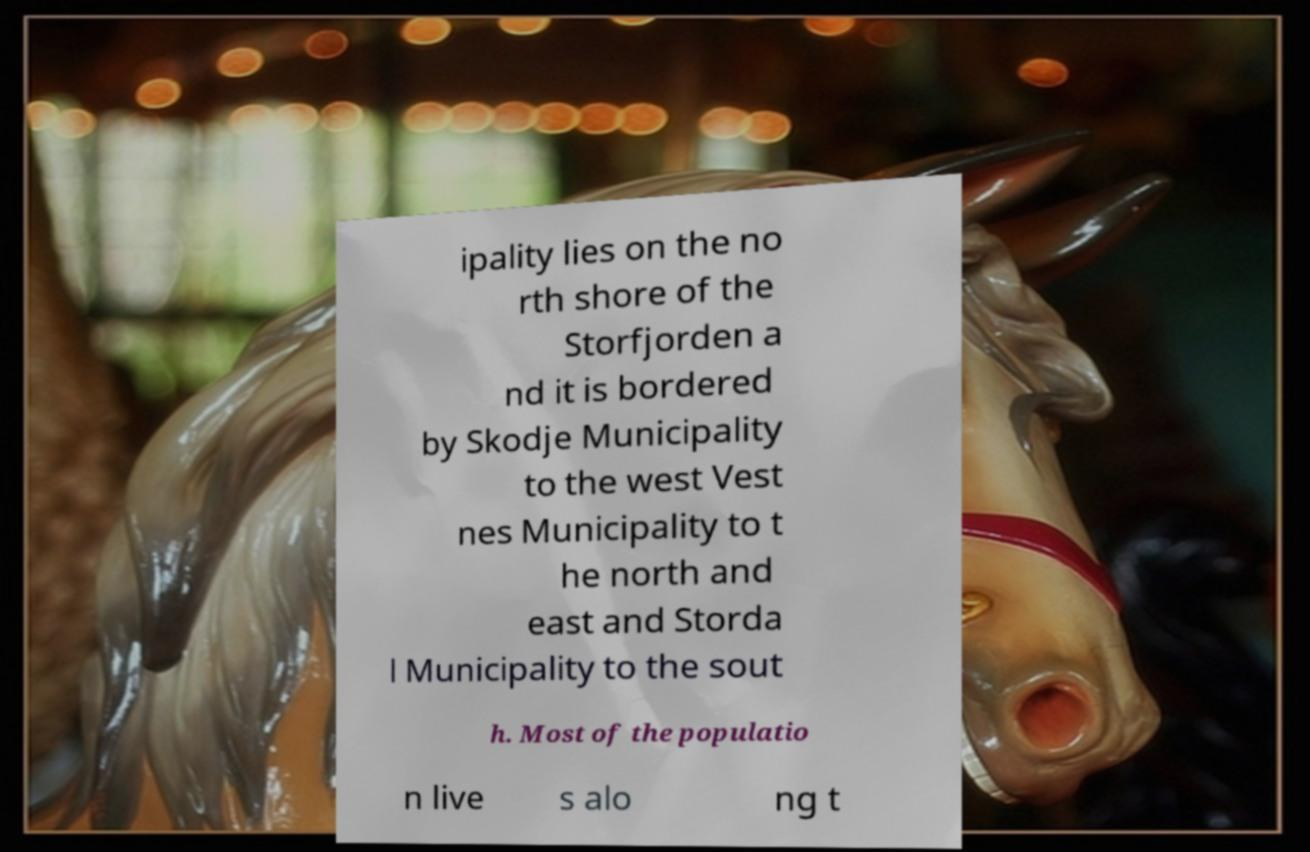Could you assist in decoding the text presented in this image and type it out clearly? ipality lies on the no rth shore of the Storfjorden a nd it is bordered by Skodje Municipality to the west Vest nes Municipality to t he north and east and Storda l Municipality to the sout h. Most of the populatio n live s alo ng t 